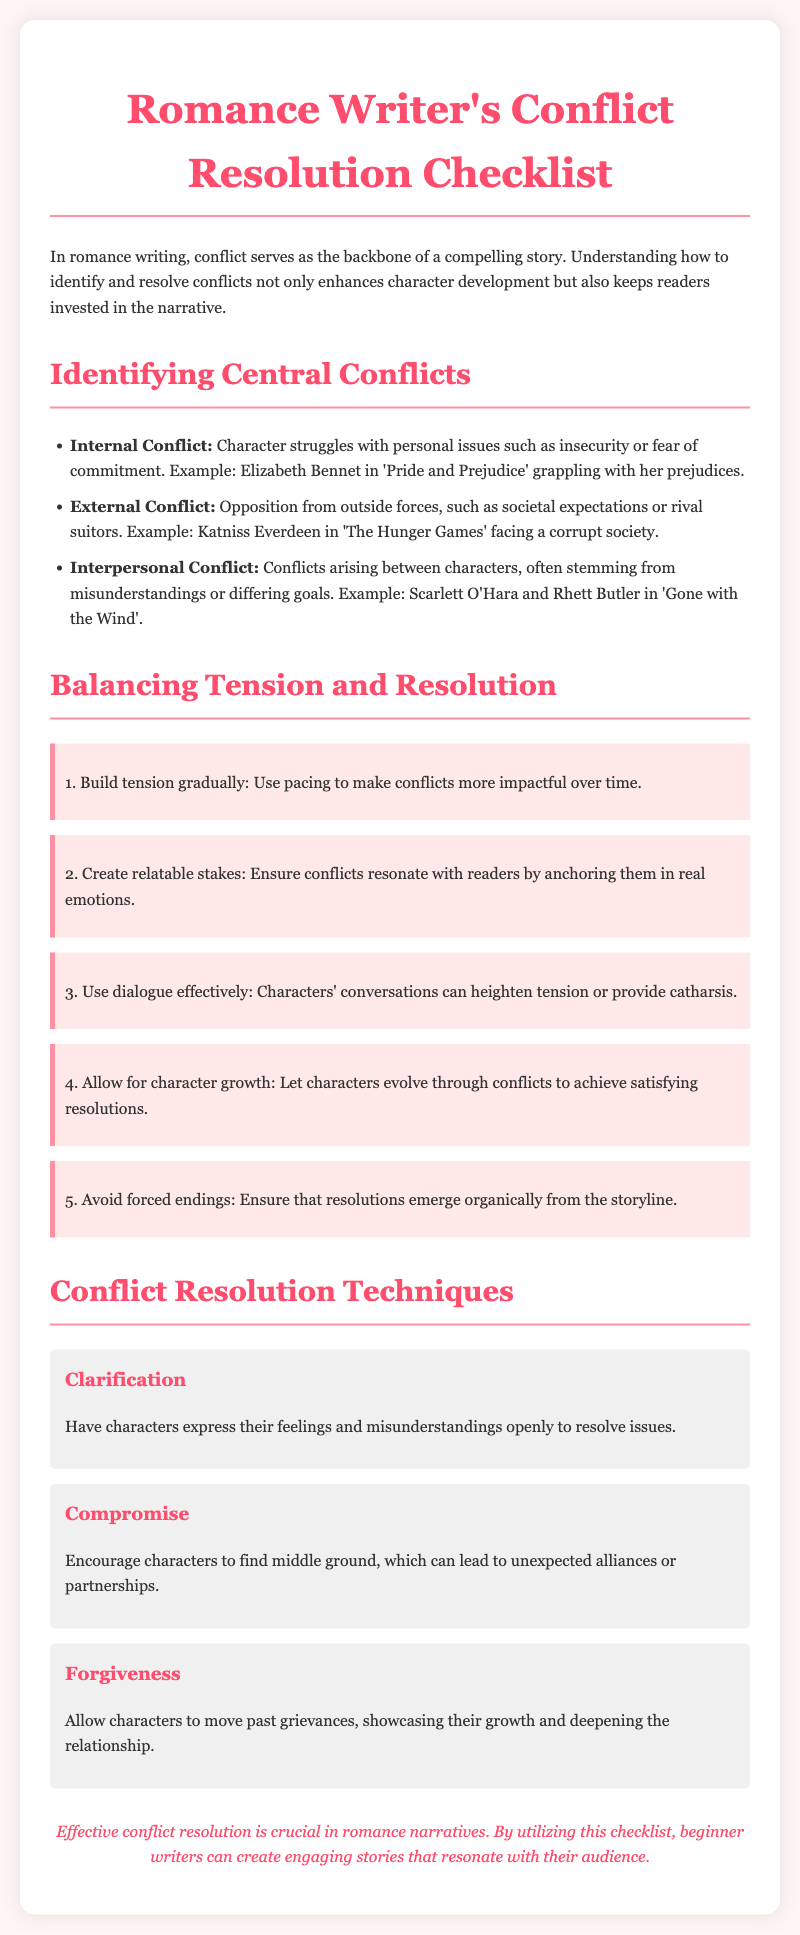What is the main purpose of conflict in romance writing? The main purpose of conflict in romance writing is to serve as the backbone of a compelling story.
Answer: Backbone What type of conflict is illustrated by Elizabeth Bennet in 'Pride and Prejudice'? Elizabeth Bennet exhibits an internal conflict as she struggles with her prejudices.
Answer: Internal Conflict Which technique encourages characters to express their feelings openly? The technique that encourages characters to express their feelings is called Clarification.
Answer: Clarification How many tips are provided for balancing tension and resolution? The document lists a total of five tips for balancing tension and resolution.
Answer: Five What is one of the suggested outcomes of using the forgiveness technique? Using the forgiveness technique allows characters to move past grievances, showcasing their growth.
Answer: Growth Which character faced a corrupt society as an external conflict? Katniss Everdeen from 'The Hunger Games' faced a corrupt society as an external conflict.
Answer: Katniss Everdeen What is a key aspect to avoid when crafting endings in romance narratives? Writers should avoid forced endings, ensuring that resolutions emerge organically.
Answer: Forced endings What color is used for the headings in the document? The color used for the headings is #ff4d6d, which is a shade of pink.
Answer: Pink 